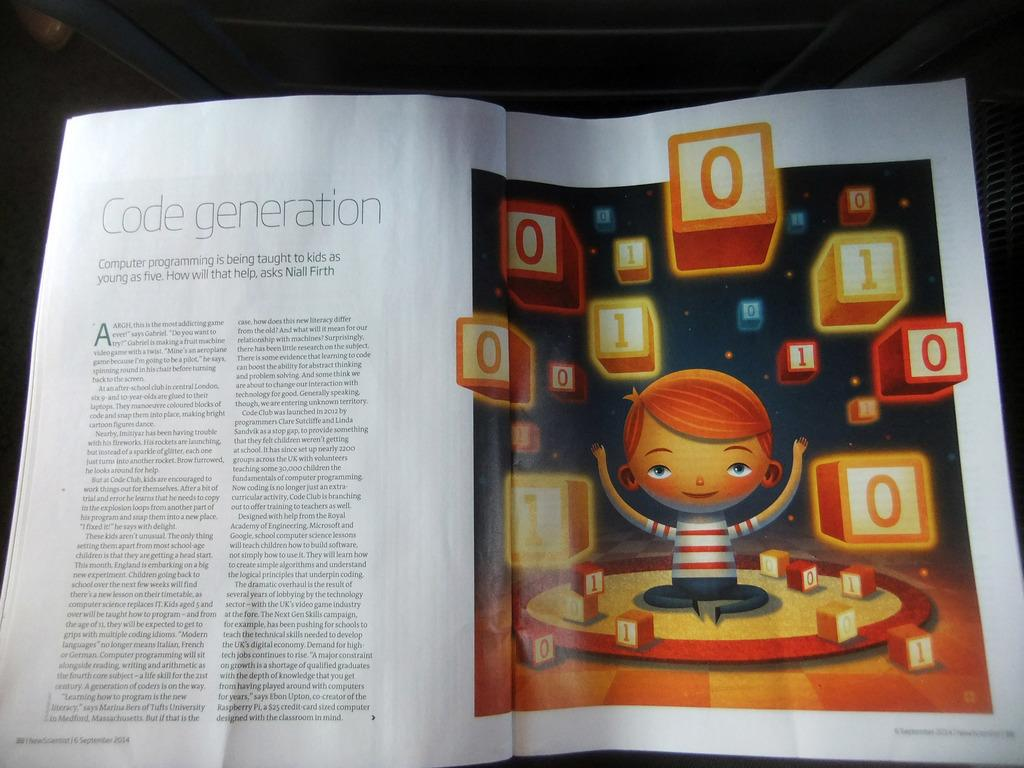<image>
Relay a brief, clear account of the picture shown. A magazine is open to an article about how kids as young as five are learning computer programming. 